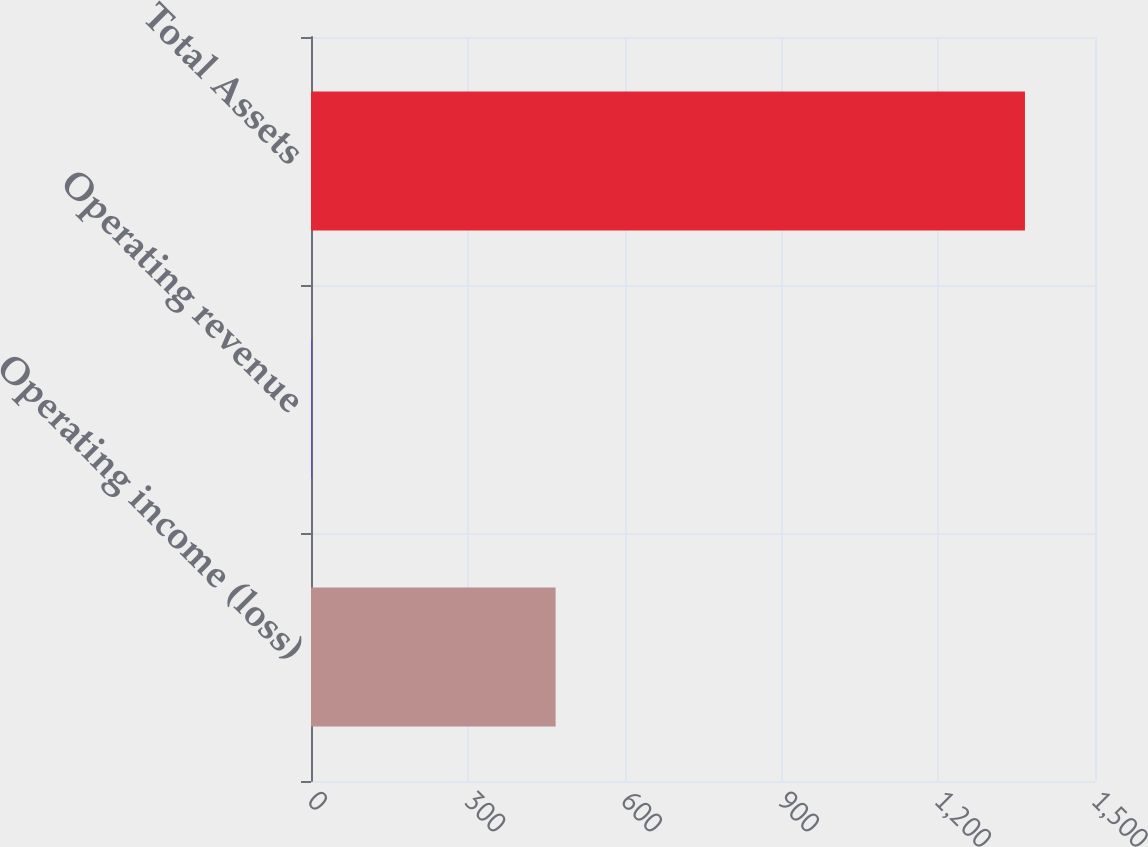<chart> <loc_0><loc_0><loc_500><loc_500><bar_chart><fcel>Operating income (loss)<fcel>Operating revenue<fcel>Total Assets<nl><fcel>468<fcel>2<fcel>1366<nl></chart> 